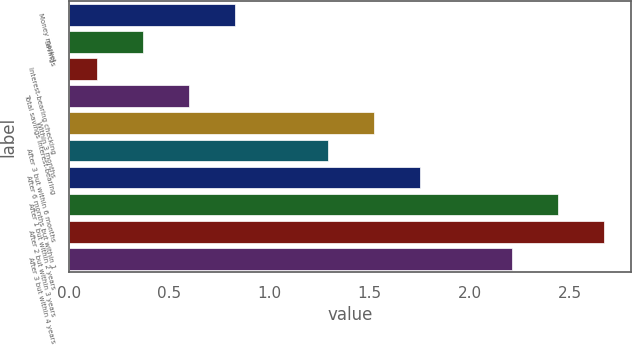Convert chart. <chart><loc_0><loc_0><loc_500><loc_500><bar_chart><fcel>Money market<fcel>Savings<fcel>Interest-bearing checking<fcel>Total savings interest-bearing<fcel>Within 3 months<fcel>After 3 but within 6 months<fcel>After 6 months but within 1<fcel>After 1 but within 2 years<fcel>After 2 but within 3 years<fcel>After 3 but within 4 years<nl><fcel>0.83<fcel>0.37<fcel>0.14<fcel>0.6<fcel>1.52<fcel>1.29<fcel>1.75<fcel>2.44<fcel>2.67<fcel>2.21<nl></chart> 